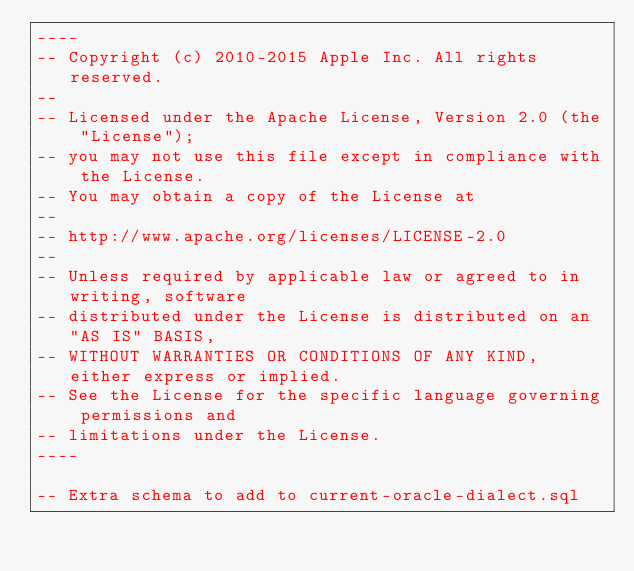<code> <loc_0><loc_0><loc_500><loc_500><_SQL_>----
-- Copyright (c) 2010-2015 Apple Inc. All rights reserved.
--
-- Licensed under the Apache License, Version 2.0 (the "License");
-- you may not use this file except in compliance with the License.
-- You may obtain a copy of the License at
--
-- http://www.apache.org/licenses/LICENSE-2.0
--
-- Unless required by applicable law or agreed to in writing, software
-- distributed under the License is distributed on an "AS IS" BASIS,
-- WITHOUT WARRANTIES OR CONDITIONS OF ANY KIND, either express or implied.
-- See the License for the specific language governing permissions and
-- limitations under the License.
----

-- Extra schema to add to current-oracle-dialect.sql
</code> 